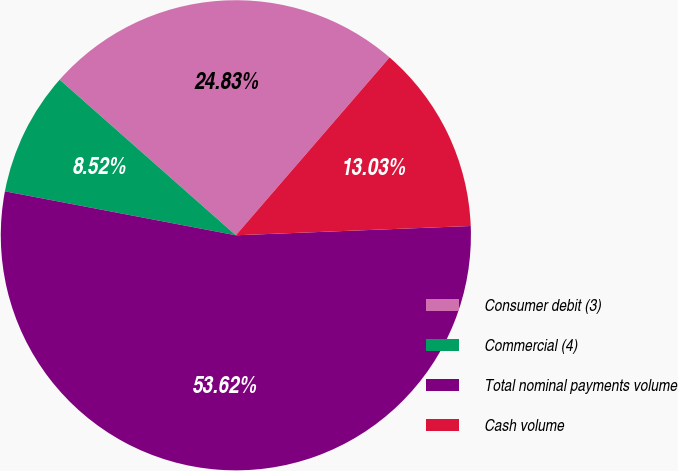Convert chart. <chart><loc_0><loc_0><loc_500><loc_500><pie_chart><fcel>Consumer debit (3)<fcel>Commercial (4)<fcel>Total nominal payments volume<fcel>Cash volume<nl><fcel>24.83%<fcel>8.52%<fcel>53.63%<fcel>13.03%<nl></chart> 